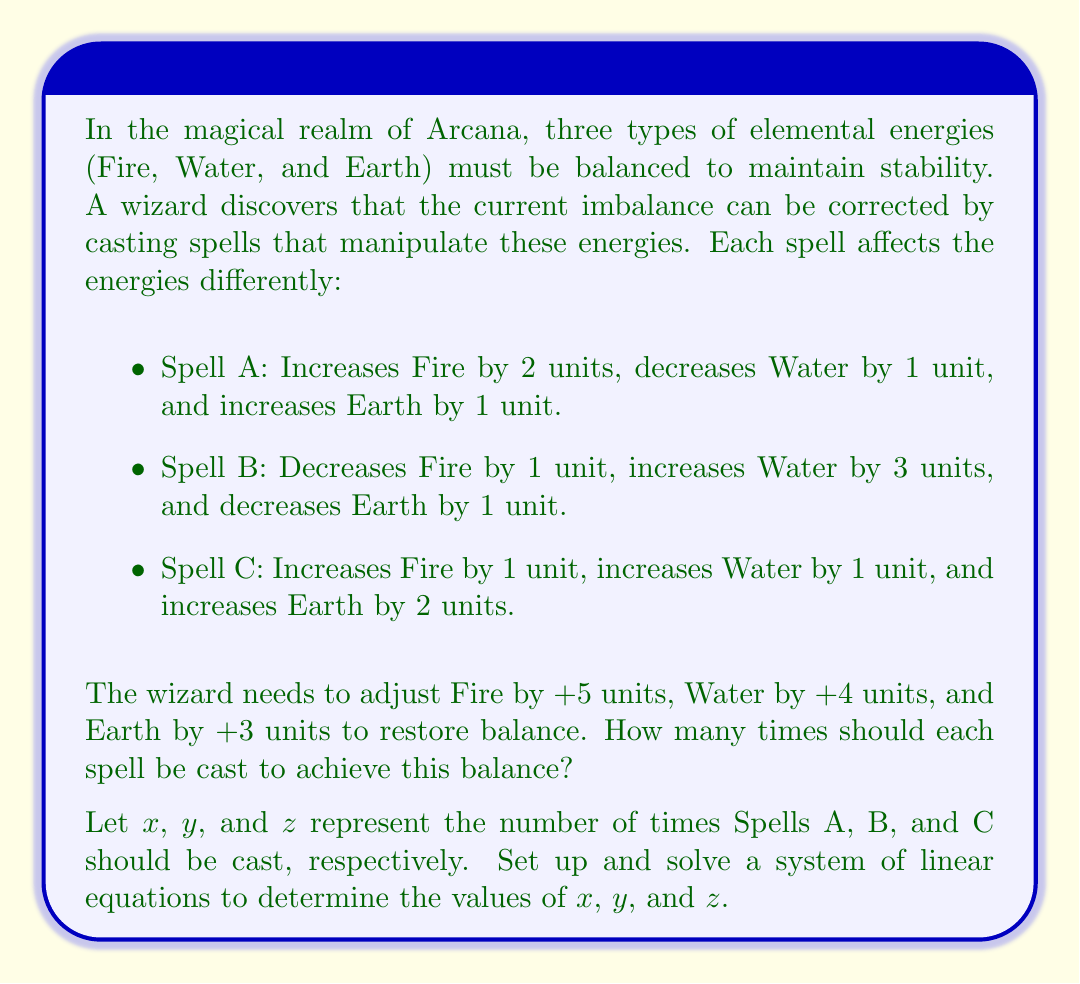Solve this math problem. To solve this problem, we'll follow these steps:

1. Set up the system of linear equations
2. Convert the equations into matrix form
3. Solve the system using Gaussian elimination or matrix inversion

Step 1: Set up the system of linear equations

Based on the given information, we can set up three equations representing the changes in Fire, Water, and Earth energies:

Fire: $2x - y + z = 5$
Water: $-x + 3y + z = 4$
Earth: $x - y + 2z = 3$

Step 2: Convert the equations into matrix form

We can represent this system in matrix form as $A\mathbf{X} = \mathbf{B}$:

$$
\begin{bmatrix}
2 & -1 & 1 \\
-1 & 3 & 1 \\
1 & -1 & 2
\end{bmatrix}
\begin{bmatrix}
x \\
y \\
z
\end{bmatrix}
=
\begin{bmatrix}
5 \\
4 \\
3
\end{bmatrix}
$$

Step 3: Solve the system using Gaussian elimination

We'll use Gaussian elimination to solve this system:

$$
\begin{bmatrix}
2 & -1 & 1 & | & 5 \\
-1 & 3 & 1 & | & 4 \\
1 & -1 & 2 & | & 3
\end{bmatrix}
$$

Multiply the first row by 1/2 and add it to the second row:

$$
\begin{bmatrix}
2 & -1 & 1 & | & 5 \\
0 & 5/2 & 3/2 & | & 13/2 \\
1 & -1 & 2 & | & 3
\end{bmatrix}
$$

Subtract the first row from the third row:

$$
\begin{bmatrix}
2 & -1 & 1 & | & 5 \\
0 & 5/2 & 3/2 & | & 13/2 \\
-1 & 0 & 1 & | & -2
\end{bmatrix}
$$

Add 1/2 of the second row to the third row:

$$
\begin{bmatrix}
2 & -1 & 1 & | & 5 \\
0 & 5/2 & 3/2 & | & 13/2 \\
0 & 5/4 & 11/4 & | & 9/4
\end{bmatrix}
$$

Subtract 1/2 of the second row from the first row:

$$
\begin{bmatrix}
2 & 0 & 1/4 & | & 11/4 \\
0 & 5/2 & 3/2 & | & 13/2 \\
0 & 5/4 & 11/4 & | & 9/4
\end{bmatrix}
$$

Subtract 1/2 of the third row from the second row:

$$
\begin{bmatrix}
2 & 0 & 1/4 & | & 11/4 \\
0 & 5/2 & 0 & | & 5 \\
0 & 5/4 & 11/4 & | & 9/4
\end{bmatrix}
$$

Now we have an upper triangular matrix. We can solve for $y$, then $z$, and finally $x$:

$y = 5 \div (5/2) = 2$

$11z/4 + 5/4 \cdot 2 = 9/4$
$11z/4 = 9/4 - 10/4 = -1/4$
$z = (-1/4) \div (11/4) = -1/11$

$2x + 1/4 \cdot (-1/11) = 11/4$
$2x = 11/4 + 1/44 = 121/44$
$x = 121/88 = 11/8$

Step 4: Verify the solution

We can verify that these values satisfy the original equations:

Fire: $2(11/8) - 2 + (-1/11) = 11/4 - 2 - 1/11 = 5$
Water: $-(11/8) + 3(2) + (-1/11) = -11/8 + 6 - 1/11 = 4$
Earth: $11/8 - 2 + 2(-1/11) = 11/8 - 2 - 2/11 = 3$

The solution satisfies all equations, confirming its correctness.
Answer: Spell A should be cast $11/8$ (or approximately 1.375) times, Spell B should be cast 2 times, and Spell C should be cast $-1/11$ (or approximately -0.091) times. Since it's not possible to cast fractional or negative spells, the wizard would need to find a way to cast partial spells or combine these results with other magical techniques to achieve the exact balance. 